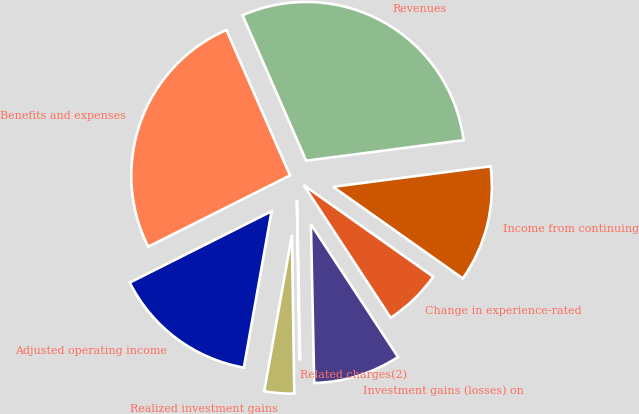Convert chart to OTSL. <chart><loc_0><loc_0><loc_500><loc_500><pie_chart><fcel>Revenues<fcel>Benefits and expenses<fcel>Adjusted operating income<fcel>Realized investment gains<fcel>Related charges(2)<fcel>Investment gains (losses) on<fcel>Change in experience-rated<fcel>Income from continuing<nl><fcel>29.5%<fcel>25.85%<fcel>14.79%<fcel>3.03%<fcel>0.09%<fcel>8.91%<fcel>5.97%<fcel>11.85%<nl></chart> 